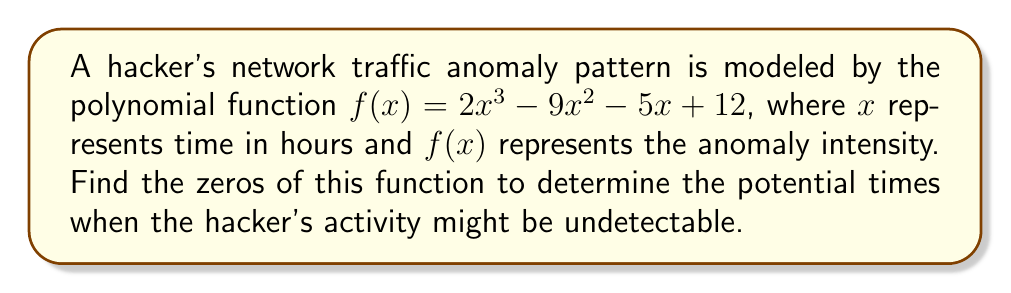Can you answer this question? To find the zeros of the polynomial function $f(x) = 2x^3 - 9x^2 - 5x + 12$, we need to factor it and solve for x when $f(x) = 0$.

Step 1: Check for rational roots using the rational root theorem.
Possible rational roots: $\pm 1, \pm 2, \pm 3, \pm 4, \pm 6, \pm 12$

Step 2: Use synthetic division to test these roots.
We find that 3 is a root.

Step 3: Factor out $(x - 3)$:
$f(x) = (x - 3)(2x^2 + 3x - 4)$

Step 4: Use the quadratic formula to solve $2x^2 + 3x - 4 = 0$
$x = \frac{-b \pm \sqrt{b^2 - 4ac}}{2a}$
$x = \frac{-3 \pm \sqrt{3^2 - 4(2)(-4)}}{2(2)}$
$x = \frac{-3 \pm \sqrt{41}}{4}$

Step 5: Simplify the results:
$x_1 = 3$
$x_2 = \frac{-3 + \sqrt{41}}{4} \approx 1$
$x_3 = \frac{-3 - \sqrt{41}}{4} \approx -2$

Therefore, the zeros of the function are 3, $\frac{-3 + \sqrt{41}}{4}$, and $\frac{-3 - \sqrt{41}}{4}$.
Answer: $x = 3, \frac{-3 + \sqrt{41}}{4}, \frac{-3 - \sqrt{41}}{4}$ 